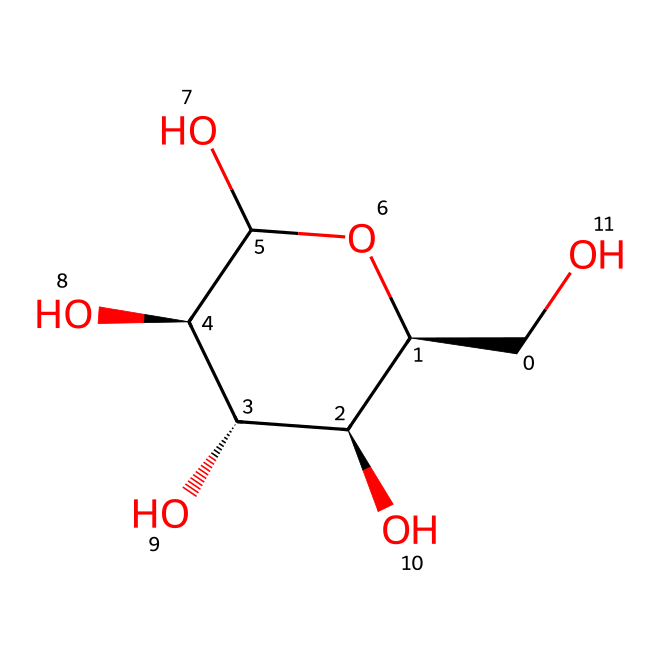What is the molecular formula of glucose? To determine the molecular formula, we count the atoms of each element in the structure. In the given SMILES, we can see 6 carbon (C) atoms, 12 hydrogen (H) atoms, and 6 oxygen (O) atoms. This gives us the formula C6H12O6.
Answer: C6H12O6 How many hydroxyl groups are present in glucose? We can identify the hydroxyl groups (–OH) by looking at the structure. In the visual representation, there are 5 –OH groups attached to the carbon skeleton.
Answer: 5 What type of isomerism is exhibited by glucose? The molecular structure of glucose includes multiple stereocenters, which indicates that glucose can exhibit stereoisomerism (specifically, it has multiple chiral centers).
Answer: stereoisomerism What type of compound is glucose classified as? Glucose is classified as an aliphatic compound because it contains a long chain of carbon atoms arranged in a linear or branched form without aromatic rings.
Answer: aliphatic How many chiral centers are present in glucose? By analyzing the structure, we find that glucose has 4 chiral centers, which are located at specific carbon atoms that have four different substituents.
Answer: 4 What functional groups are present in glucose? In the structure, we observe hydroxyl groups (–OH) and an aldehyde group (–CHO) at the first carbon. These functional groups define its reactivity and properties.
Answer: hydroxyl and aldehyde 